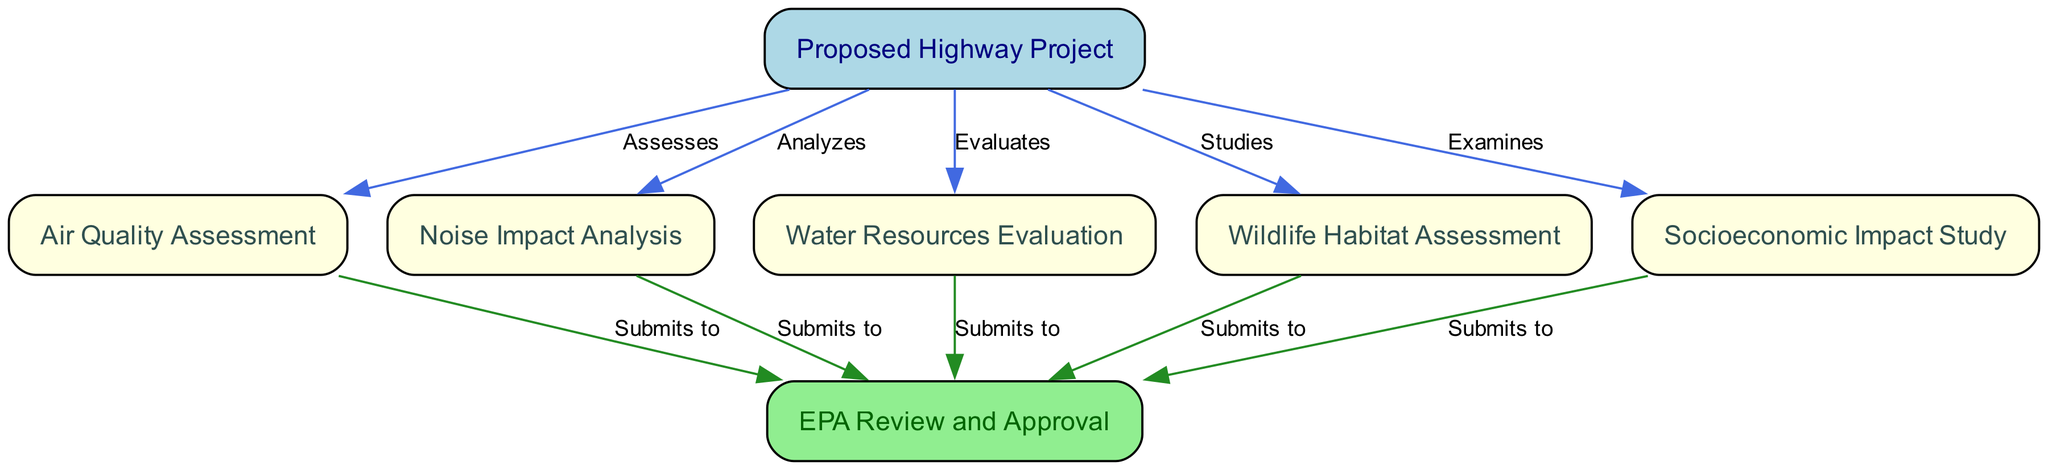What is the label of node 1? Node 1 is labeled as "Proposed Highway Project" as indicated directly on the diagram.
Answer: Proposed Highway Project How many nodes are there in total? The diagram lists a total of 7 nodes. Each node corresponds to a specific assessment aspect related to the proposed highway project.
Answer: 7 What relationship exists between the proposed highway project and air quality assessment? The relationship is defined by the label "Assesses" on the edge that connects Node 1 (Proposed Highway Project) to Node 2 (Air Quality Assessment).
Answer: Assesses What is the final step after submitting the analysis of wildlife habitat? The final step is the "EPA Review and Approval" which is represented as the endpoint node (Node 7) that receives submissions from various analyses.
Answer: EPA Review and Approval Which two assessments feed directly into the EPA review and approval? The "Air Quality Assessment" and "Noise Impact Analysis" both submit their findings to the EPA for review, as indicated by direct edges leading to Node 7 from Nodes 2 and 3.
Answer: Air Quality Assessment, Noise Impact Analysis How many evaluations lead to the EPA review and approval? There are 5 individual assessments (Air Quality, Noise Impact, Water Resources, Wildlife Habitat, Socioeconomic) that all submit their findings to the EPA for review.
Answer: 5 What label is associated with the edge from water resources evaluation to the EPA review? The edge connecting Node 4 (Water Resources Evaluation) to Node 7 (EPA Review and Approval) is labeled "Submits to" which indicates the action taken.
Answer: Submits to Considering all assessments, which area does the proposed highway project not analyze? Based on the nodes in the diagram, the proposed highway project does not analyze "Cultural Heritage", which is not represented in the diagram at all.
Answer: Cultural Heritage What type of study is performed alongside socioeconomic impact study? The "Wildlife Habitat Assessment" is studied concurrently with the "Socioeconomic Impact Study", both of which are directly linked to the proposed highway project.
Answer: Wildlife Habitat Assessment 